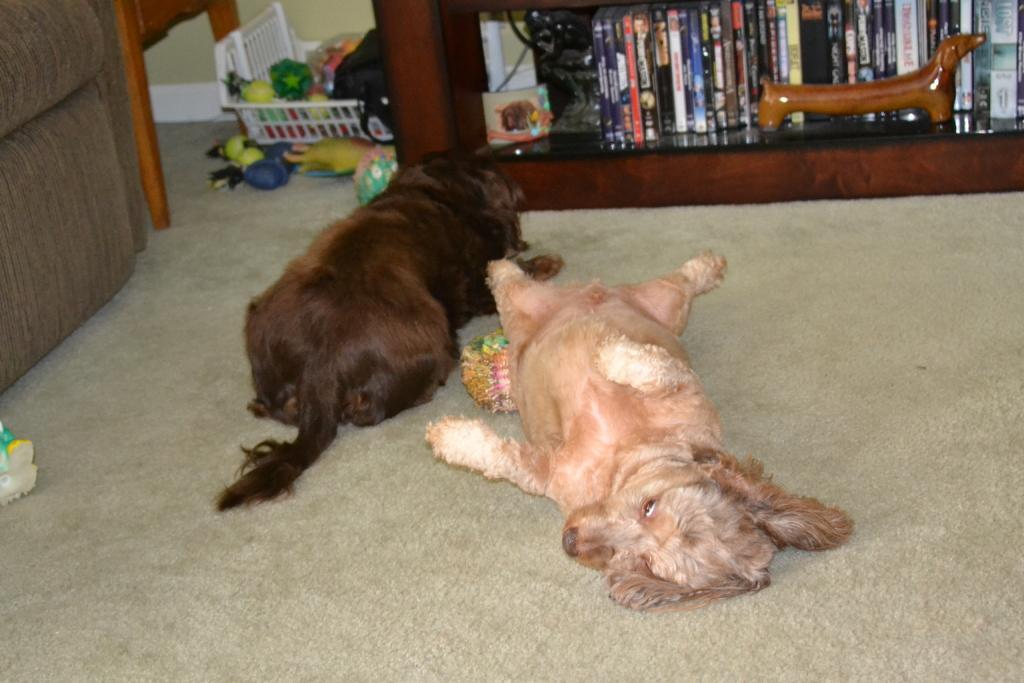In one or two sentences, can you explain what this image depicts? In the image there are two dogs lying on a carpet and behind them there are many toys kept in a tray and on the right side there are a lot of books in a shelf. 